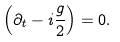Convert formula to latex. <formula><loc_0><loc_0><loc_500><loc_500>\left ( \partial _ { t } - i { \frac { g } { 2 } } \right ) = 0 .</formula> 